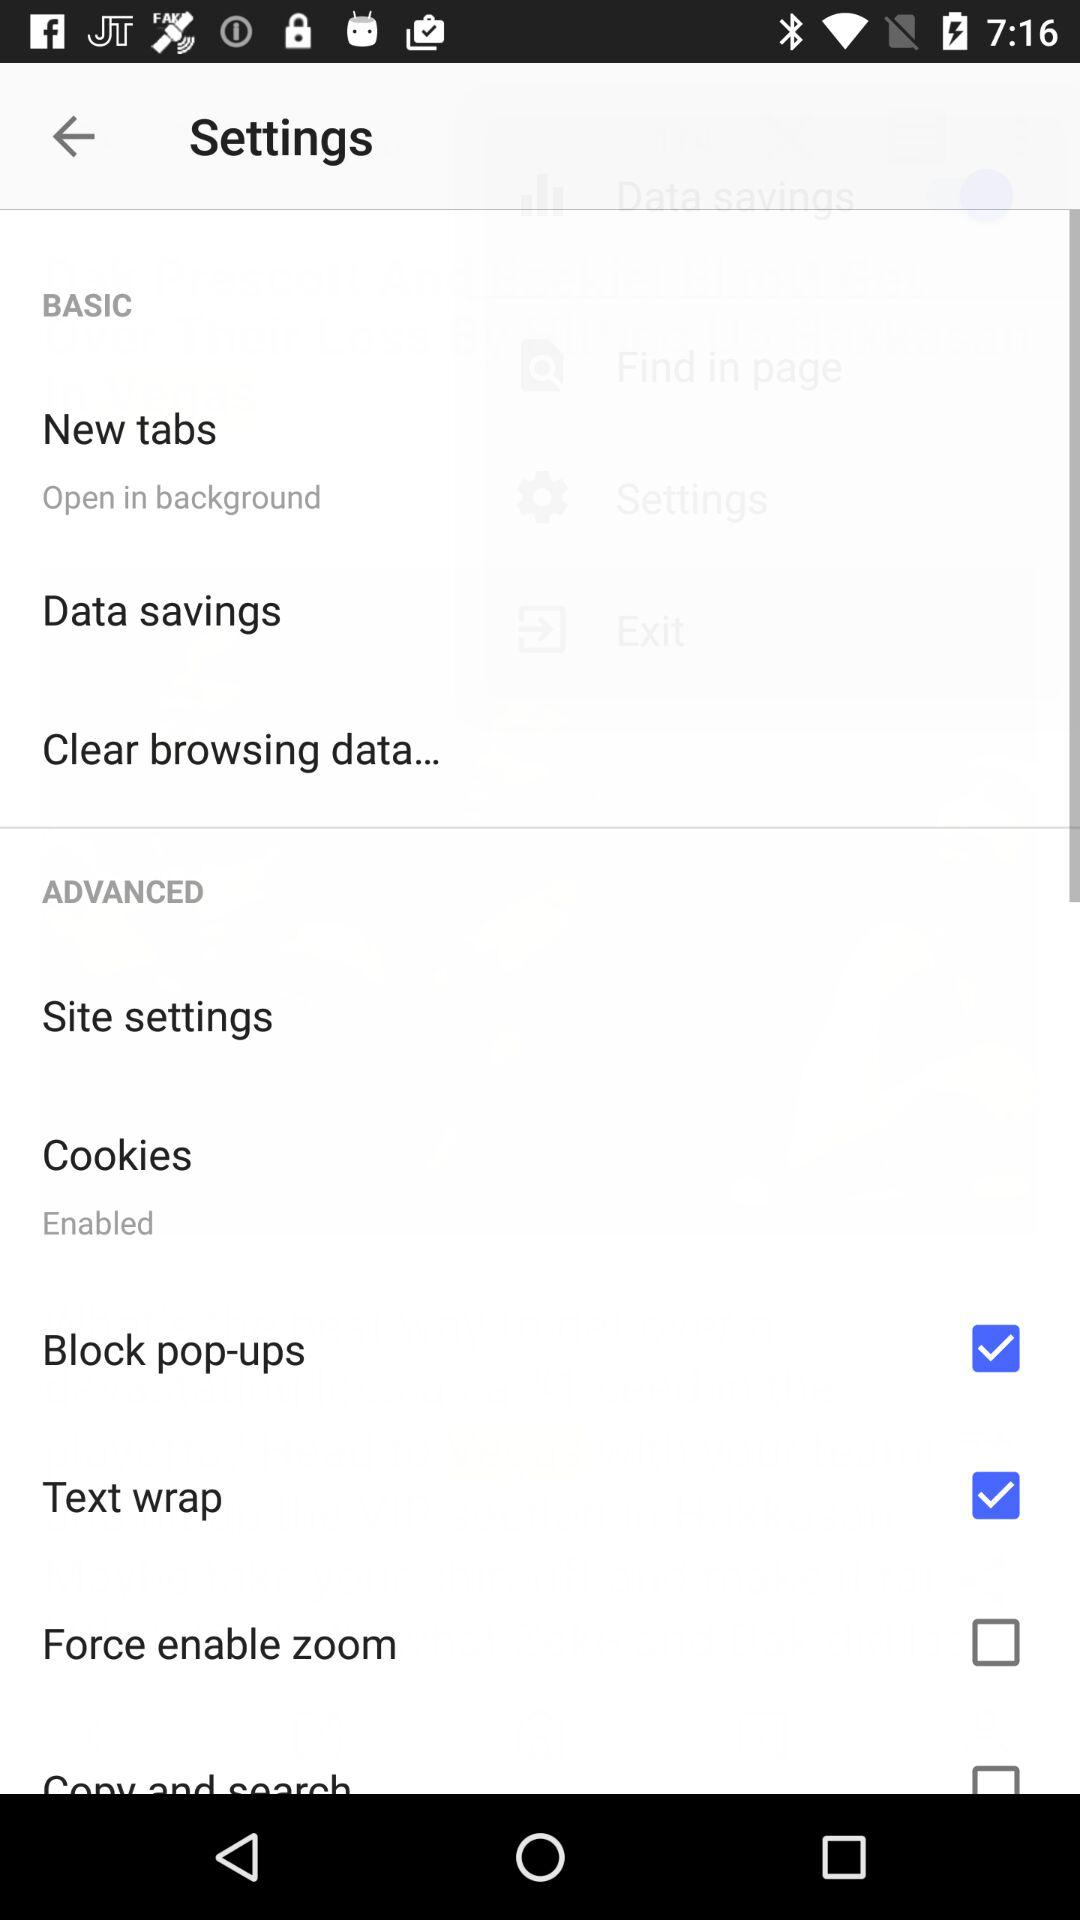What is the setting for cookies? The setting for cookies is "Enabled". 